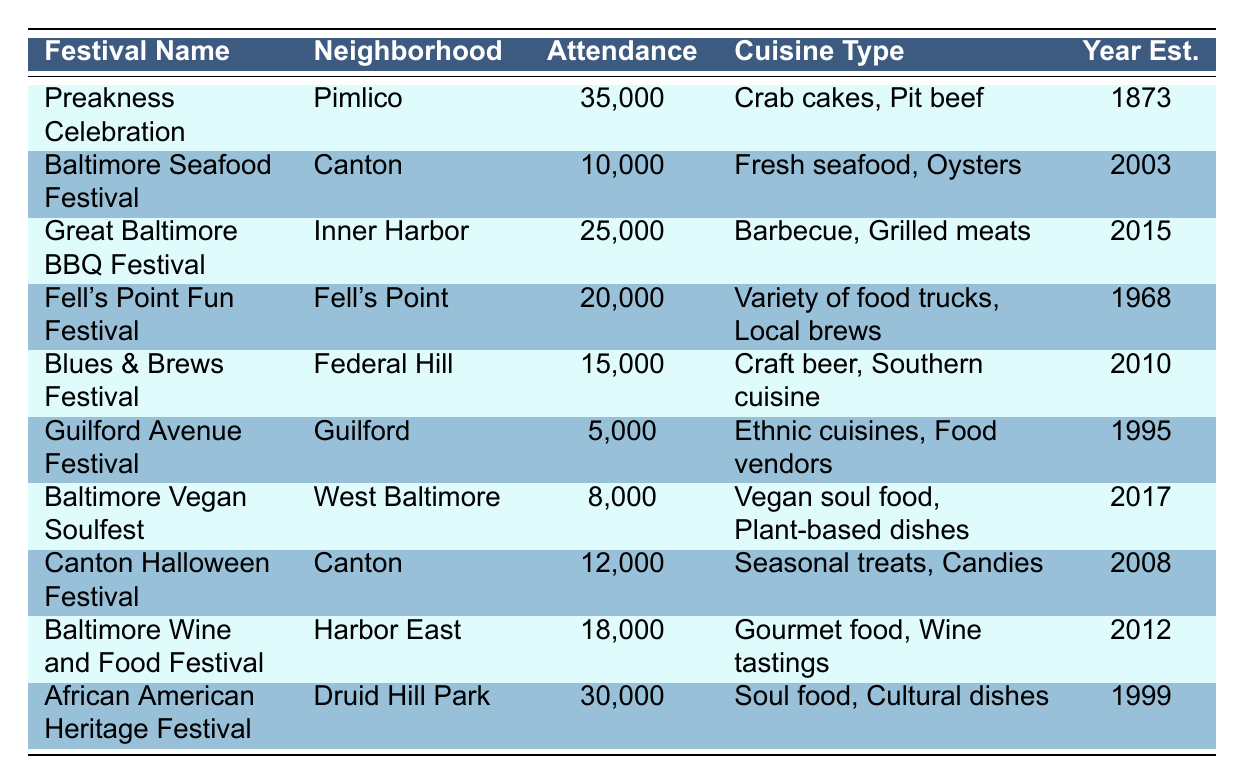What is the attendance rate of the Preakness Celebration? The attendance rate for the Preakness Celebration can be found directly in the table. It shows an attendance rate of 35,000.
Answer: 35,000 Which festival has the highest attendance rate? To determine the highest attendance rate, we compare the attendance rates listed in the table. The Preakness Celebration has the highest rate at 35,000, followed by the African American Heritage Festival at 30,000.
Answer: Preakness Celebration What is the average attendance rate of all the festivals listed? The attendance rates are 35,000, 10,000, 25,000, 20,000, 15,000, 5,000, 8,000, 12,000, 18,000, and 30,000. Adding these together gives 35,000 + 10,000 + 25,000 + 20,000 + 15,000 + 5,000 + 8,000 + 12,000 + 18,000 + 30,000 =  378,000. Dividing by the number of festivals (10), the average attendance rate is 378,000 / 10 = 37,800.
Answer: 37,800 Is there a food festival in Canton that features fresh seafood? The table lists the Baltimore Seafood Festival and the Canton Halloween Festival in Canton. The Baltimore Seafood Festival features fresh seafood, which confirms that there is such a festival.
Answer: Yes How much higher is the attendance rate of the Great Baltimore BBQ Festival compared to the Guilford Avenue Festival? The Great Baltimore BBQ Festival has an attendance rate of 25,000, while the Guilford Avenue Festival has an attendance rate of 5,000. The difference between 25,000 and 5,000 is 20,000, indicating it is significantly higher.
Answer: 20,000 Are there any festivals that were established after the year 2010 with an attendance rate over 10,000? Looking at the table, the Great Baltimore BBQ Festival (established in 2015) and the Baltimore Vegan Soulfest (established in 2017) both have attendance rates that exceed 10,000. Therefore, there are such festivals.
Answer: Yes What cuisine types are featured at the Fell's Point Fun Festival? The table lists the Fell's Point Fun Festival under the Cuisine Type column, revealing it features a variety of food trucks and local brews. This provides insight into the festival's culinary offerings.
Answer: Variety of food trucks, Local brews What is the total attendance rate for festivals established before 2000? The festivals established before 2000 are the Preakness Celebration (1873), the Fell's Point Fun Festival (1968), and the Guilford Avenue Festival (1995). Their attendance rates are 35,000, 20,000, and 5,000 respectively. Summing these gives: 35,000 + 20,000 + 5,000 = 60,000.
Answer: 60,000 